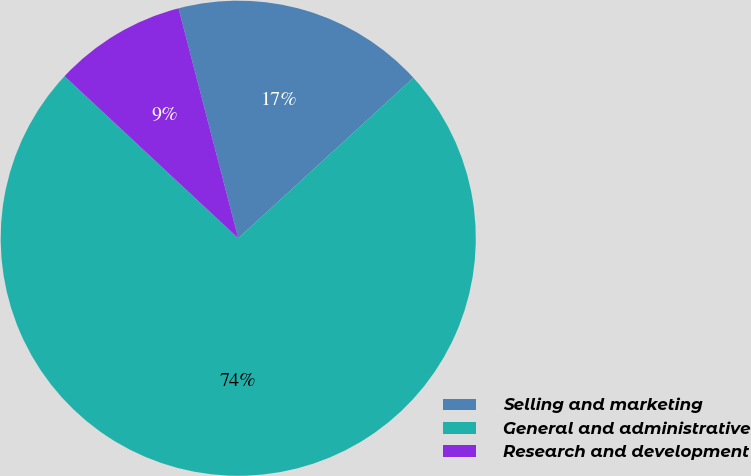Convert chart to OTSL. <chart><loc_0><loc_0><loc_500><loc_500><pie_chart><fcel>Selling and marketing<fcel>General and administrative<fcel>Research and development<nl><fcel>17.24%<fcel>73.75%<fcel>9.01%<nl></chart> 